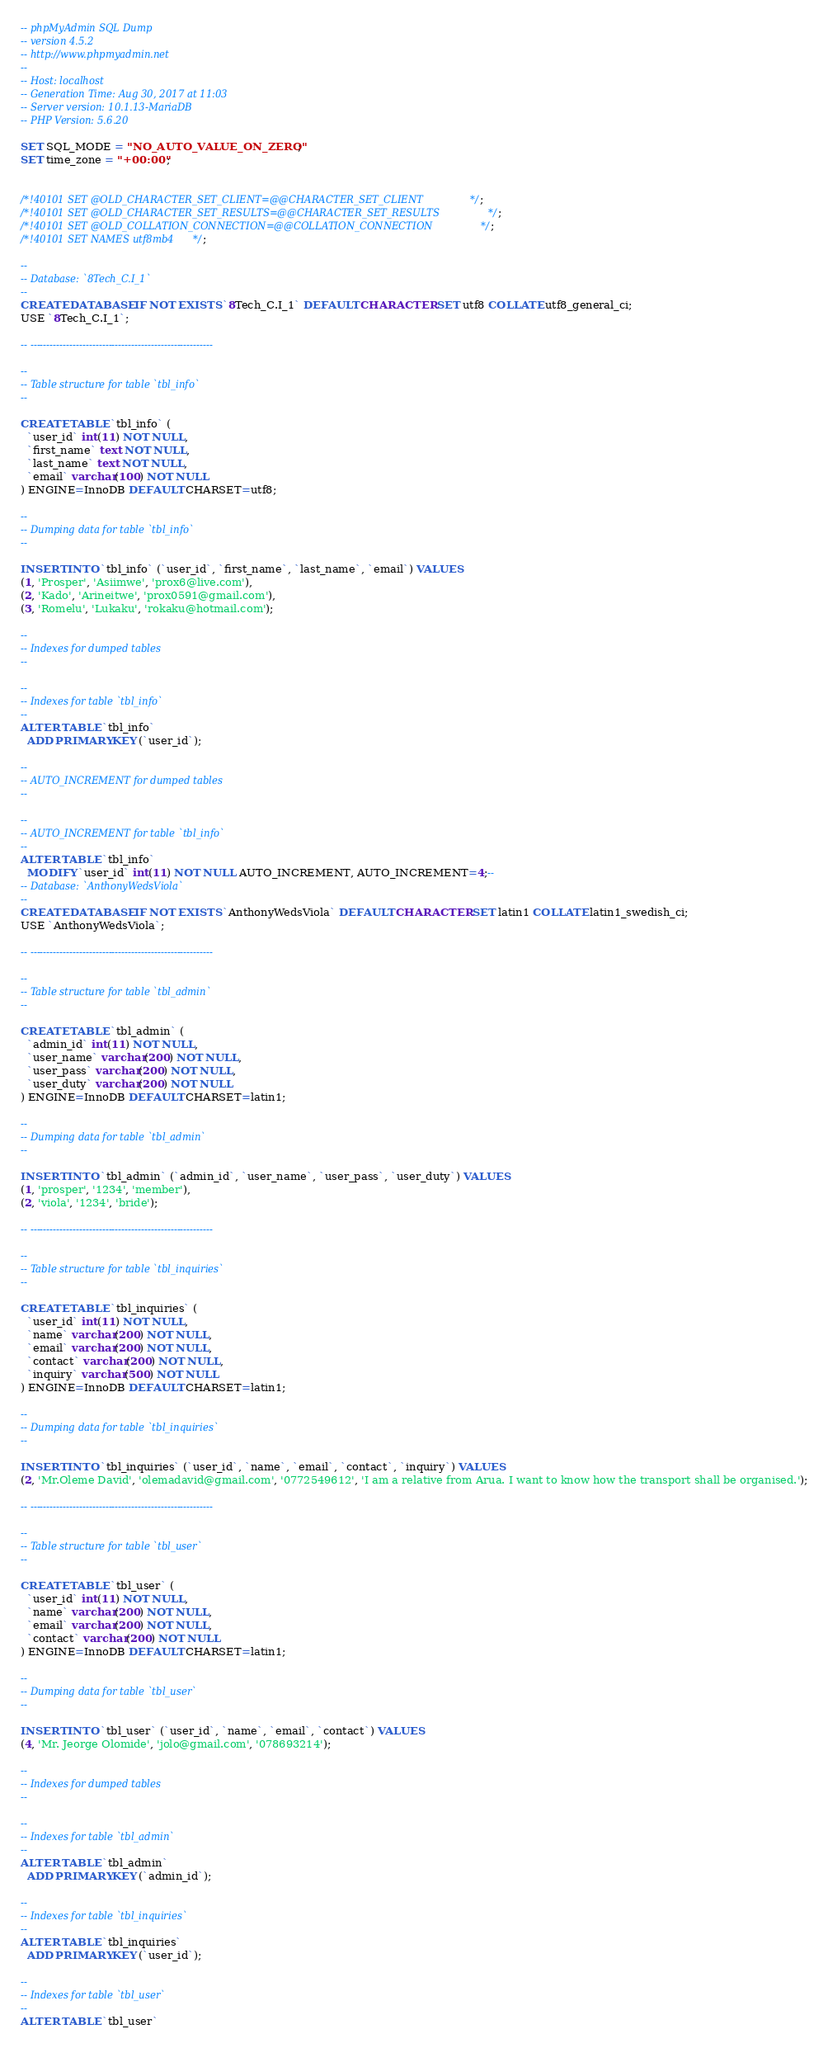Convert code to text. <code><loc_0><loc_0><loc_500><loc_500><_SQL_>-- phpMyAdmin SQL Dump
-- version 4.5.2
-- http://www.phpmyadmin.net
--
-- Host: localhost
-- Generation Time: Aug 30, 2017 at 11:03 
-- Server version: 10.1.13-MariaDB
-- PHP Version: 5.6.20

SET SQL_MODE = "NO_AUTO_VALUE_ON_ZERO";
SET time_zone = "+00:00";


/*!40101 SET @OLD_CHARACTER_SET_CLIENT=@@CHARACTER_SET_CLIENT */;
/*!40101 SET @OLD_CHARACTER_SET_RESULTS=@@CHARACTER_SET_RESULTS */;
/*!40101 SET @OLD_COLLATION_CONNECTION=@@COLLATION_CONNECTION */;
/*!40101 SET NAMES utf8mb4 */;

--
-- Database: `8Tech_C.I_1`
--
CREATE DATABASE IF NOT EXISTS `8Tech_C.I_1` DEFAULT CHARACTER SET utf8 COLLATE utf8_general_ci;
USE `8Tech_C.I_1`;

-- --------------------------------------------------------

--
-- Table structure for table `tbl_info`
--

CREATE TABLE `tbl_info` (
  `user_id` int(11) NOT NULL,
  `first_name` text NOT NULL,
  `last_name` text NOT NULL,
  `email` varchar(100) NOT NULL
) ENGINE=InnoDB DEFAULT CHARSET=utf8;

--
-- Dumping data for table `tbl_info`
--

INSERT INTO `tbl_info` (`user_id`, `first_name`, `last_name`, `email`) VALUES
(1, 'Prosper', 'Asiimwe', 'prox6@live.com'),
(2, 'Kado', 'Arineitwe', 'prox0591@gmail.com'),
(3, 'Romelu', 'Lukaku', 'rokaku@hotmail.com');

--
-- Indexes for dumped tables
--

--
-- Indexes for table `tbl_info`
--
ALTER TABLE `tbl_info`
  ADD PRIMARY KEY (`user_id`);

--
-- AUTO_INCREMENT for dumped tables
--

--
-- AUTO_INCREMENT for table `tbl_info`
--
ALTER TABLE `tbl_info`
  MODIFY `user_id` int(11) NOT NULL AUTO_INCREMENT, AUTO_INCREMENT=4;--
-- Database: `AnthonyWedsViola`
--
CREATE DATABASE IF NOT EXISTS `AnthonyWedsViola` DEFAULT CHARACTER SET latin1 COLLATE latin1_swedish_ci;
USE `AnthonyWedsViola`;

-- --------------------------------------------------------

--
-- Table structure for table `tbl_admin`
--

CREATE TABLE `tbl_admin` (
  `admin_id` int(11) NOT NULL,
  `user_name` varchar(200) NOT NULL,
  `user_pass` varchar(200) NOT NULL,
  `user_duty` varchar(200) NOT NULL
) ENGINE=InnoDB DEFAULT CHARSET=latin1;

--
-- Dumping data for table `tbl_admin`
--

INSERT INTO `tbl_admin` (`admin_id`, `user_name`, `user_pass`, `user_duty`) VALUES
(1, 'prosper', '1234', 'member'),
(2, 'viola', '1234', 'bride');

-- --------------------------------------------------------

--
-- Table structure for table `tbl_inquiries`
--

CREATE TABLE `tbl_inquiries` (
  `user_id` int(11) NOT NULL,
  `name` varchar(200) NOT NULL,
  `email` varchar(200) NOT NULL,
  `contact` varchar(200) NOT NULL,
  `inquiry` varchar(500) NOT NULL
) ENGINE=InnoDB DEFAULT CHARSET=latin1;

--
-- Dumping data for table `tbl_inquiries`
--

INSERT INTO `tbl_inquiries` (`user_id`, `name`, `email`, `contact`, `inquiry`) VALUES
(2, 'Mr.Oleme David', 'olemadavid@gmail.com', '0772549612', 'I am a relative from Arua. I want to know how the transport shall be organised.');

-- --------------------------------------------------------

--
-- Table structure for table `tbl_user`
--

CREATE TABLE `tbl_user` (
  `user_id` int(11) NOT NULL,
  `name` varchar(200) NOT NULL,
  `email` varchar(200) NOT NULL,
  `contact` varchar(200) NOT NULL
) ENGINE=InnoDB DEFAULT CHARSET=latin1;

--
-- Dumping data for table `tbl_user`
--

INSERT INTO `tbl_user` (`user_id`, `name`, `email`, `contact`) VALUES
(4, 'Mr. Jeorge Olomide', 'jolo@gmail.com', '078693214');

--
-- Indexes for dumped tables
--

--
-- Indexes for table `tbl_admin`
--
ALTER TABLE `tbl_admin`
  ADD PRIMARY KEY (`admin_id`);

--
-- Indexes for table `tbl_inquiries`
--
ALTER TABLE `tbl_inquiries`
  ADD PRIMARY KEY (`user_id`);

--
-- Indexes for table `tbl_user`
--
ALTER TABLE `tbl_user`</code> 